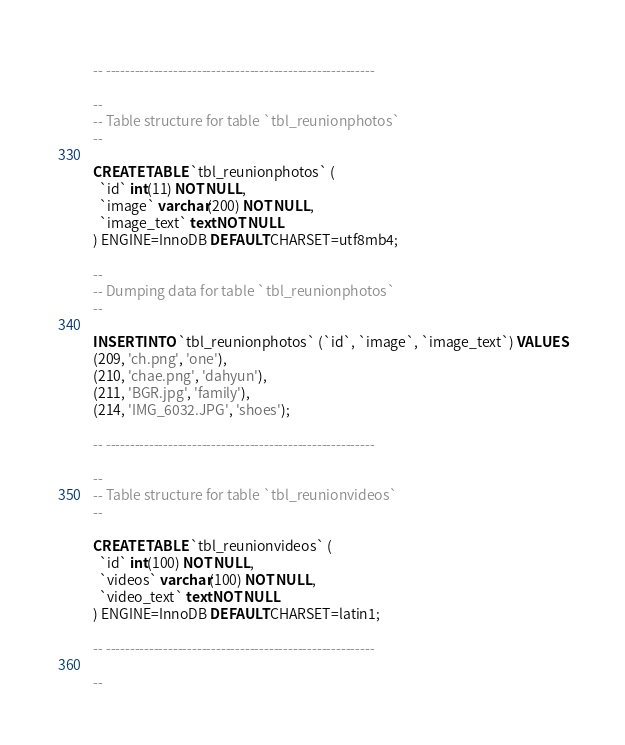Convert code to text. <code><loc_0><loc_0><loc_500><loc_500><_SQL_>
-- --------------------------------------------------------

--
-- Table structure for table `tbl_reunionphotos`
--

CREATE TABLE `tbl_reunionphotos` (
  `id` int(11) NOT NULL,
  `image` varchar(200) NOT NULL,
  `image_text` text NOT NULL
) ENGINE=InnoDB DEFAULT CHARSET=utf8mb4;

--
-- Dumping data for table `tbl_reunionphotos`
--

INSERT INTO `tbl_reunionphotos` (`id`, `image`, `image_text`) VALUES
(209, 'ch.png', 'one'),
(210, 'chae.png', 'dahyun'),
(211, 'BGR.jpg', 'family'),
(214, 'IMG_6032.JPG', 'shoes');

-- --------------------------------------------------------

--
-- Table structure for table `tbl_reunionvideos`
--

CREATE TABLE `tbl_reunionvideos` (
  `id` int(100) NOT NULL,
  `videos` varchar(100) NOT NULL,
  `video_text` text NOT NULL
) ENGINE=InnoDB DEFAULT CHARSET=latin1;

-- --------------------------------------------------------

--</code> 